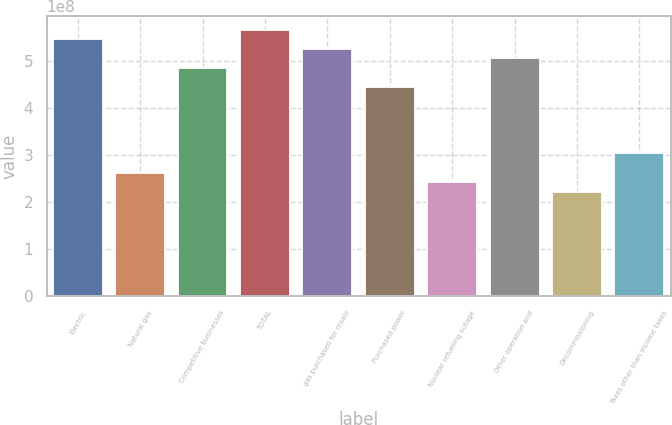Convert chart to OTSL. <chart><loc_0><loc_0><loc_500><loc_500><bar_chart><fcel>Electric<fcel>Natural gas<fcel>Competitive businesses<fcel>TOTAL<fcel>gas purchased for resale<fcel>Purchased power<fcel>Nuclear refueling outage<fcel>Other operation and<fcel>Decommissioning<fcel>Taxes other than income taxes<nl><fcel>5.47507e+08<fcel>2.63614e+08<fcel>4.86673e+08<fcel>5.67785e+08<fcel>5.27229e+08<fcel>4.46117e+08<fcel>2.43336e+08<fcel>5.06951e+08<fcel>2.23058e+08<fcel>3.0417e+08<nl></chart> 